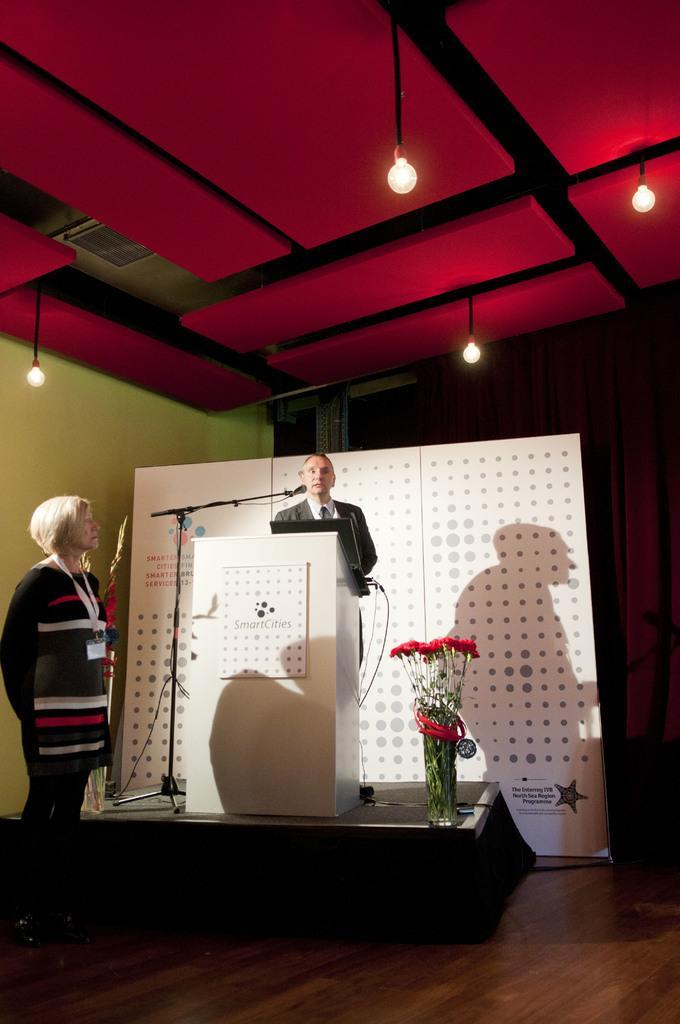Please provide a concise description of this image. The man in front of the picture is standing. In front of him, we see a podium on which laptop is placed. Beside that, we see a microphone. I think he is talking on the microphone. Beside that, we see a flower pot. On the left side, we see a woman is standing. Behind him, we see a white color board. In the background, we see a wall in green and brown color. At the top of the picture, we see the lights and the ceiling of the room. This picture is clicked in the conference hall. 